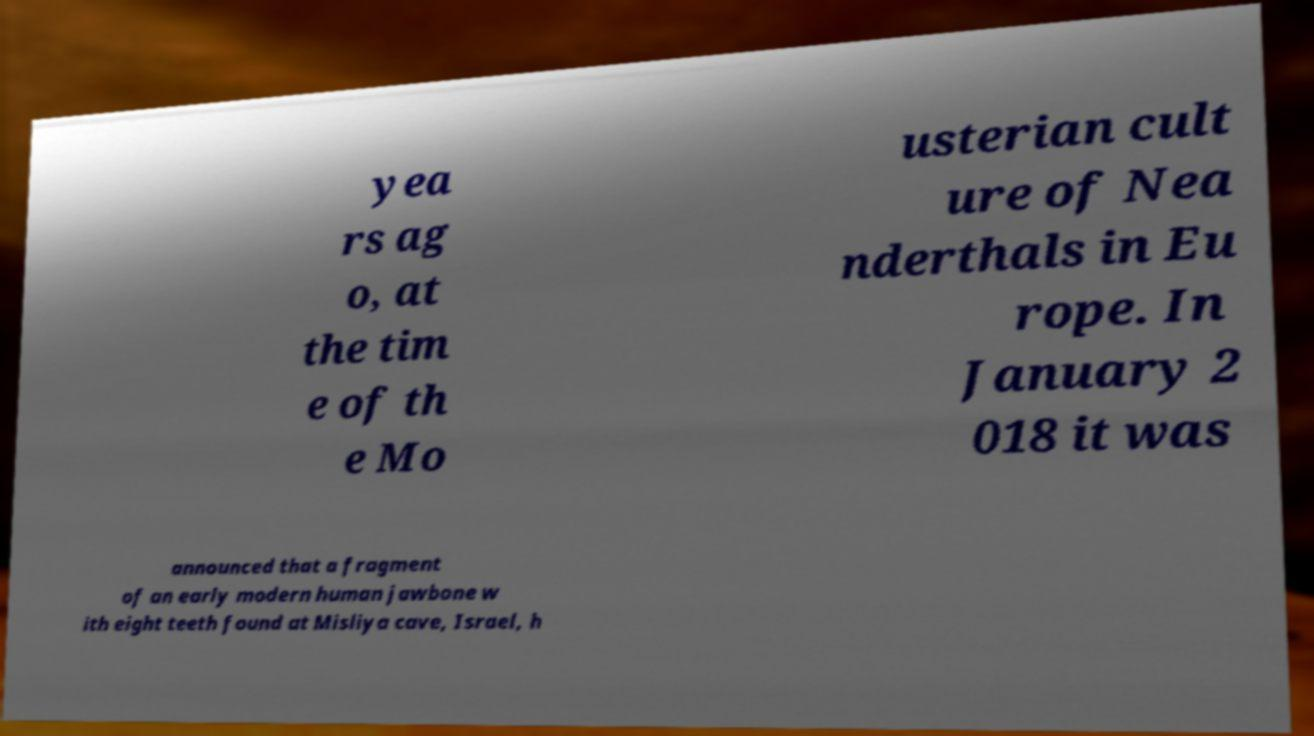I need the written content from this picture converted into text. Can you do that? yea rs ag o, at the tim e of th e Mo usterian cult ure of Nea nderthals in Eu rope. In January 2 018 it was announced that a fragment of an early modern human jawbone w ith eight teeth found at Misliya cave, Israel, h 